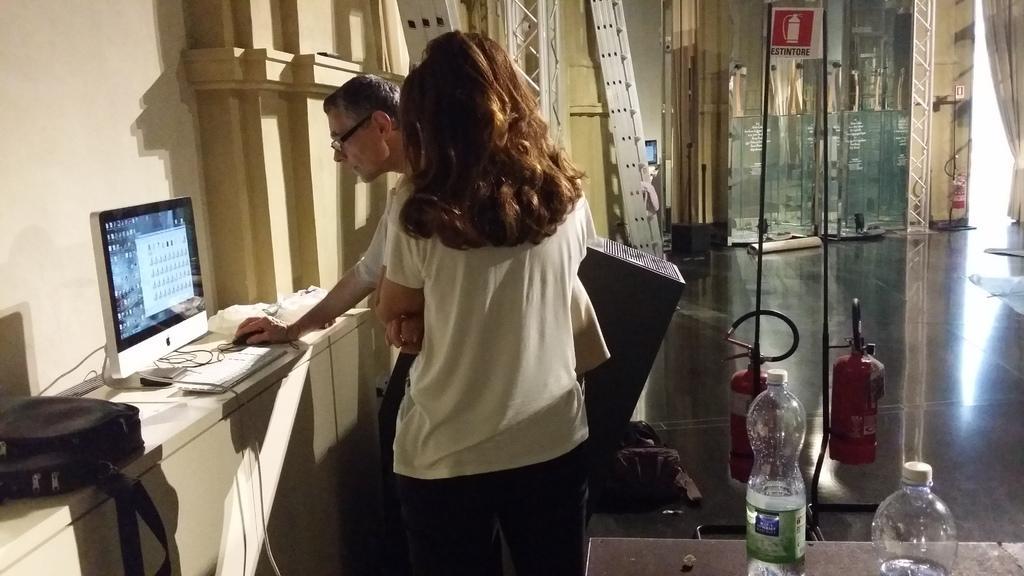In one or two sentences, can you explain what this image depicts? This is the picture of two people who are standing in front of the desk on which there is a bag and a system and behind them there is a table on which there are some bottles and some gas cylinders. 